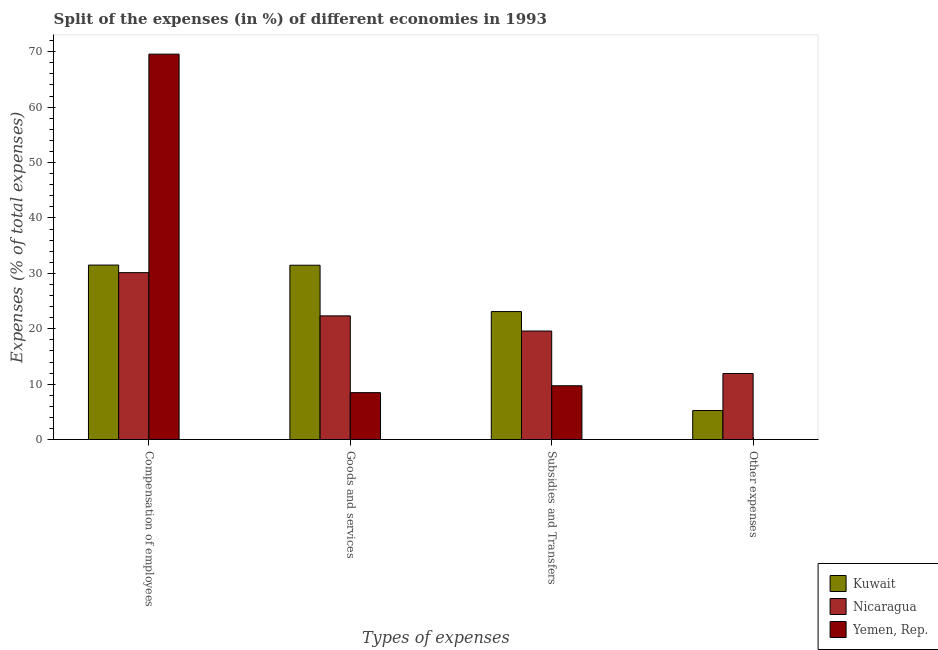How many bars are there on the 3rd tick from the right?
Provide a succinct answer. 3. What is the label of the 1st group of bars from the left?
Offer a terse response. Compensation of employees. What is the percentage of amount spent on subsidies in Kuwait?
Ensure brevity in your answer.  23.1. Across all countries, what is the maximum percentage of amount spent on other expenses?
Provide a succinct answer. 11.92. Across all countries, what is the minimum percentage of amount spent on other expenses?
Make the answer very short. 0. In which country was the percentage of amount spent on compensation of employees maximum?
Provide a succinct answer. Yemen, Rep. In which country was the percentage of amount spent on compensation of employees minimum?
Provide a succinct answer. Nicaragua. What is the total percentage of amount spent on compensation of employees in the graph?
Offer a very short reply. 131.18. What is the difference between the percentage of amount spent on other expenses in Yemen, Rep. and that in Kuwait?
Your answer should be very brief. -5.24. What is the difference between the percentage of amount spent on compensation of employees in Kuwait and the percentage of amount spent on subsidies in Yemen, Rep.?
Ensure brevity in your answer.  21.78. What is the average percentage of amount spent on other expenses per country?
Your response must be concise. 5.72. What is the difference between the percentage of amount spent on compensation of employees and percentage of amount spent on other expenses in Nicaragua?
Provide a short and direct response. 18.2. In how many countries, is the percentage of amount spent on subsidies greater than 28 %?
Your answer should be very brief. 0. What is the ratio of the percentage of amount spent on other expenses in Nicaragua to that in Kuwait?
Offer a terse response. 2.27. Is the difference between the percentage of amount spent on other expenses in Yemen, Rep. and Nicaragua greater than the difference between the percentage of amount spent on compensation of employees in Yemen, Rep. and Nicaragua?
Your answer should be compact. No. What is the difference between the highest and the second highest percentage of amount spent on goods and services?
Provide a succinct answer. 9.14. What is the difference between the highest and the lowest percentage of amount spent on goods and services?
Your answer should be very brief. 22.99. Is the sum of the percentage of amount spent on subsidies in Nicaragua and Kuwait greater than the maximum percentage of amount spent on goods and services across all countries?
Offer a very short reply. Yes. What does the 1st bar from the left in Compensation of employees represents?
Your response must be concise. Kuwait. What does the 1st bar from the right in Other expenses represents?
Offer a terse response. Yemen, Rep. How many bars are there?
Your answer should be very brief. 12. Are all the bars in the graph horizontal?
Ensure brevity in your answer.  No. How many countries are there in the graph?
Your answer should be very brief. 3. Does the graph contain grids?
Your response must be concise. No. Where does the legend appear in the graph?
Offer a very short reply. Bottom right. How many legend labels are there?
Provide a short and direct response. 3. How are the legend labels stacked?
Your answer should be compact. Vertical. What is the title of the graph?
Your answer should be compact. Split of the expenses (in %) of different economies in 1993. What is the label or title of the X-axis?
Provide a succinct answer. Types of expenses. What is the label or title of the Y-axis?
Ensure brevity in your answer.  Expenses (% of total expenses). What is the Expenses (% of total expenses) of Kuwait in Compensation of employees?
Offer a terse response. 31.5. What is the Expenses (% of total expenses) of Nicaragua in Compensation of employees?
Give a very brief answer. 30.13. What is the Expenses (% of total expenses) in Yemen, Rep. in Compensation of employees?
Give a very brief answer. 69.55. What is the Expenses (% of total expenses) of Kuwait in Goods and services?
Ensure brevity in your answer.  31.47. What is the Expenses (% of total expenses) of Nicaragua in Goods and services?
Give a very brief answer. 22.33. What is the Expenses (% of total expenses) in Yemen, Rep. in Goods and services?
Your response must be concise. 8.47. What is the Expenses (% of total expenses) of Kuwait in Subsidies and Transfers?
Offer a very short reply. 23.1. What is the Expenses (% of total expenses) of Nicaragua in Subsidies and Transfers?
Ensure brevity in your answer.  19.59. What is the Expenses (% of total expenses) in Yemen, Rep. in Subsidies and Transfers?
Your response must be concise. 9.72. What is the Expenses (% of total expenses) in Kuwait in Other expenses?
Provide a succinct answer. 5.24. What is the Expenses (% of total expenses) of Nicaragua in Other expenses?
Offer a very short reply. 11.92. What is the Expenses (% of total expenses) in Yemen, Rep. in Other expenses?
Your response must be concise. 0. Across all Types of expenses, what is the maximum Expenses (% of total expenses) of Kuwait?
Your answer should be very brief. 31.5. Across all Types of expenses, what is the maximum Expenses (% of total expenses) in Nicaragua?
Your response must be concise. 30.13. Across all Types of expenses, what is the maximum Expenses (% of total expenses) in Yemen, Rep.?
Offer a very short reply. 69.55. Across all Types of expenses, what is the minimum Expenses (% of total expenses) in Kuwait?
Provide a short and direct response. 5.24. Across all Types of expenses, what is the minimum Expenses (% of total expenses) of Nicaragua?
Give a very brief answer. 11.92. Across all Types of expenses, what is the minimum Expenses (% of total expenses) in Yemen, Rep.?
Give a very brief answer. 0. What is the total Expenses (% of total expenses) of Kuwait in the graph?
Offer a terse response. 91.31. What is the total Expenses (% of total expenses) in Nicaragua in the graph?
Keep it short and to the point. 83.97. What is the total Expenses (% of total expenses) of Yemen, Rep. in the graph?
Provide a succinct answer. 87.75. What is the difference between the Expenses (% of total expenses) in Kuwait in Compensation of employees and that in Goods and services?
Make the answer very short. 0.03. What is the difference between the Expenses (% of total expenses) of Nicaragua in Compensation of employees and that in Goods and services?
Provide a succinct answer. 7.8. What is the difference between the Expenses (% of total expenses) of Yemen, Rep. in Compensation of employees and that in Goods and services?
Keep it short and to the point. 61.08. What is the difference between the Expenses (% of total expenses) in Kuwait in Compensation of employees and that in Subsidies and Transfers?
Provide a short and direct response. 8.39. What is the difference between the Expenses (% of total expenses) in Nicaragua in Compensation of employees and that in Subsidies and Transfers?
Your response must be concise. 10.53. What is the difference between the Expenses (% of total expenses) of Yemen, Rep. in Compensation of employees and that in Subsidies and Transfers?
Provide a short and direct response. 59.84. What is the difference between the Expenses (% of total expenses) in Kuwait in Compensation of employees and that in Other expenses?
Provide a succinct answer. 26.25. What is the difference between the Expenses (% of total expenses) of Nicaragua in Compensation of employees and that in Other expenses?
Make the answer very short. 18.2. What is the difference between the Expenses (% of total expenses) of Yemen, Rep. in Compensation of employees and that in Other expenses?
Ensure brevity in your answer.  69.55. What is the difference between the Expenses (% of total expenses) in Kuwait in Goods and services and that in Subsidies and Transfers?
Your response must be concise. 8.36. What is the difference between the Expenses (% of total expenses) of Nicaragua in Goods and services and that in Subsidies and Transfers?
Your answer should be compact. 2.74. What is the difference between the Expenses (% of total expenses) in Yemen, Rep. in Goods and services and that in Subsidies and Transfers?
Keep it short and to the point. -1.24. What is the difference between the Expenses (% of total expenses) in Kuwait in Goods and services and that in Other expenses?
Keep it short and to the point. 26.22. What is the difference between the Expenses (% of total expenses) in Nicaragua in Goods and services and that in Other expenses?
Keep it short and to the point. 10.41. What is the difference between the Expenses (% of total expenses) in Yemen, Rep. in Goods and services and that in Other expenses?
Give a very brief answer. 8.47. What is the difference between the Expenses (% of total expenses) in Kuwait in Subsidies and Transfers and that in Other expenses?
Provide a short and direct response. 17.86. What is the difference between the Expenses (% of total expenses) of Nicaragua in Subsidies and Transfers and that in Other expenses?
Offer a very short reply. 7.67. What is the difference between the Expenses (% of total expenses) in Yemen, Rep. in Subsidies and Transfers and that in Other expenses?
Offer a terse response. 9.72. What is the difference between the Expenses (% of total expenses) in Kuwait in Compensation of employees and the Expenses (% of total expenses) in Nicaragua in Goods and services?
Your response must be concise. 9.17. What is the difference between the Expenses (% of total expenses) in Kuwait in Compensation of employees and the Expenses (% of total expenses) in Yemen, Rep. in Goods and services?
Keep it short and to the point. 23.02. What is the difference between the Expenses (% of total expenses) in Nicaragua in Compensation of employees and the Expenses (% of total expenses) in Yemen, Rep. in Goods and services?
Your answer should be compact. 21.65. What is the difference between the Expenses (% of total expenses) of Kuwait in Compensation of employees and the Expenses (% of total expenses) of Nicaragua in Subsidies and Transfers?
Your answer should be compact. 11.9. What is the difference between the Expenses (% of total expenses) of Kuwait in Compensation of employees and the Expenses (% of total expenses) of Yemen, Rep. in Subsidies and Transfers?
Provide a short and direct response. 21.78. What is the difference between the Expenses (% of total expenses) of Nicaragua in Compensation of employees and the Expenses (% of total expenses) of Yemen, Rep. in Subsidies and Transfers?
Ensure brevity in your answer.  20.41. What is the difference between the Expenses (% of total expenses) of Kuwait in Compensation of employees and the Expenses (% of total expenses) of Nicaragua in Other expenses?
Keep it short and to the point. 19.57. What is the difference between the Expenses (% of total expenses) in Kuwait in Compensation of employees and the Expenses (% of total expenses) in Yemen, Rep. in Other expenses?
Your answer should be compact. 31.49. What is the difference between the Expenses (% of total expenses) in Nicaragua in Compensation of employees and the Expenses (% of total expenses) in Yemen, Rep. in Other expenses?
Make the answer very short. 30.13. What is the difference between the Expenses (% of total expenses) of Kuwait in Goods and services and the Expenses (% of total expenses) of Nicaragua in Subsidies and Transfers?
Ensure brevity in your answer.  11.87. What is the difference between the Expenses (% of total expenses) of Kuwait in Goods and services and the Expenses (% of total expenses) of Yemen, Rep. in Subsidies and Transfers?
Ensure brevity in your answer.  21.75. What is the difference between the Expenses (% of total expenses) of Nicaragua in Goods and services and the Expenses (% of total expenses) of Yemen, Rep. in Subsidies and Transfers?
Your answer should be very brief. 12.61. What is the difference between the Expenses (% of total expenses) in Kuwait in Goods and services and the Expenses (% of total expenses) in Nicaragua in Other expenses?
Keep it short and to the point. 19.54. What is the difference between the Expenses (% of total expenses) in Kuwait in Goods and services and the Expenses (% of total expenses) in Yemen, Rep. in Other expenses?
Your response must be concise. 31.46. What is the difference between the Expenses (% of total expenses) of Nicaragua in Goods and services and the Expenses (% of total expenses) of Yemen, Rep. in Other expenses?
Provide a succinct answer. 22.33. What is the difference between the Expenses (% of total expenses) in Kuwait in Subsidies and Transfers and the Expenses (% of total expenses) in Nicaragua in Other expenses?
Ensure brevity in your answer.  11.18. What is the difference between the Expenses (% of total expenses) of Kuwait in Subsidies and Transfers and the Expenses (% of total expenses) of Yemen, Rep. in Other expenses?
Make the answer very short. 23.1. What is the difference between the Expenses (% of total expenses) in Nicaragua in Subsidies and Transfers and the Expenses (% of total expenses) in Yemen, Rep. in Other expenses?
Your answer should be very brief. 19.59. What is the average Expenses (% of total expenses) in Kuwait per Types of expenses?
Ensure brevity in your answer.  22.83. What is the average Expenses (% of total expenses) of Nicaragua per Types of expenses?
Your answer should be very brief. 20.99. What is the average Expenses (% of total expenses) of Yemen, Rep. per Types of expenses?
Keep it short and to the point. 21.94. What is the difference between the Expenses (% of total expenses) in Kuwait and Expenses (% of total expenses) in Nicaragua in Compensation of employees?
Your answer should be very brief. 1.37. What is the difference between the Expenses (% of total expenses) in Kuwait and Expenses (% of total expenses) in Yemen, Rep. in Compensation of employees?
Give a very brief answer. -38.06. What is the difference between the Expenses (% of total expenses) of Nicaragua and Expenses (% of total expenses) of Yemen, Rep. in Compensation of employees?
Ensure brevity in your answer.  -39.43. What is the difference between the Expenses (% of total expenses) of Kuwait and Expenses (% of total expenses) of Nicaragua in Goods and services?
Offer a very short reply. 9.14. What is the difference between the Expenses (% of total expenses) in Kuwait and Expenses (% of total expenses) in Yemen, Rep. in Goods and services?
Provide a short and direct response. 22.99. What is the difference between the Expenses (% of total expenses) in Nicaragua and Expenses (% of total expenses) in Yemen, Rep. in Goods and services?
Offer a very short reply. 13.86. What is the difference between the Expenses (% of total expenses) in Kuwait and Expenses (% of total expenses) in Nicaragua in Subsidies and Transfers?
Make the answer very short. 3.51. What is the difference between the Expenses (% of total expenses) of Kuwait and Expenses (% of total expenses) of Yemen, Rep. in Subsidies and Transfers?
Make the answer very short. 13.39. What is the difference between the Expenses (% of total expenses) of Nicaragua and Expenses (% of total expenses) of Yemen, Rep. in Subsidies and Transfers?
Your answer should be compact. 9.88. What is the difference between the Expenses (% of total expenses) in Kuwait and Expenses (% of total expenses) in Nicaragua in Other expenses?
Provide a short and direct response. -6.68. What is the difference between the Expenses (% of total expenses) of Kuwait and Expenses (% of total expenses) of Yemen, Rep. in Other expenses?
Make the answer very short. 5.24. What is the difference between the Expenses (% of total expenses) in Nicaragua and Expenses (% of total expenses) in Yemen, Rep. in Other expenses?
Keep it short and to the point. 11.92. What is the ratio of the Expenses (% of total expenses) in Nicaragua in Compensation of employees to that in Goods and services?
Your answer should be compact. 1.35. What is the ratio of the Expenses (% of total expenses) in Yemen, Rep. in Compensation of employees to that in Goods and services?
Keep it short and to the point. 8.21. What is the ratio of the Expenses (% of total expenses) in Kuwait in Compensation of employees to that in Subsidies and Transfers?
Offer a terse response. 1.36. What is the ratio of the Expenses (% of total expenses) in Nicaragua in Compensation of employees to that in Subsidies and Transfers?
Keep it short and to the point. 1.54. What is the ratio of the Expenses (% of total expenses) of Yemen, Rep. in Compensation of employees to that in Subsidies and Transfers?
Your answer should be compact. 7.16. What is the ratio of the Expenses (% of total expenses) in Kuwait in Compensation of employees to that in Other expenses?
Offer a terse response. 6.01. What is the ratio of the Expenses (% of total expenses) in Nicaragua in Compensation of employees to that in Other expenses?
Ensure brevity in your answer.  2.53. What is the ratio of the Expenses (% of total expenses) in Yemen, Rep. in Compensation of employees to that in Other expenses?
Provide a short and direct response. 4.09e+04. What is the ratio of the Expenses (% of total expenses) of Kuwait in Goods and services to that in Subsidies and Transfers?
Ensure brevity in your answer.  1.36. What is the ratio of the Expenses (% of total expenses) of Nicaragua in Goods and services to that in Subsidies and Transfers?
Your response must be concise. 1.14. What is the ratio of the Expenses (% of total expenses) of Yemen, Rep. in Goods and services to that in Subsidies and Transfers?
Your answer should be very brief. 0.87. What is the ratio of the Expenses (% of total expenses) in Nicaragua in Goods and services to that in Other expenses?
Ensure brevity in your answer.  1.87. What is the ratio of the Expenses (% of total expenses) in Yemen, Rep. in Goods and services to that in Other expenses?
Your response must be concise. 4982. What is the ratio of the Expenses (% of total expenses) of Kuwait in Subsidies and Transfers to that in Other expenses?
Your answer should be very brief. 4.41. What is the ratio of the Expenses (% of total expenses) of Nicaragua in Subsidies and Transfers to that in Other expenses?
Offer a terse response. 1.64. What is the ratio of the Expenses (% of total expenses) in Yemen, Rep. in Subsidies and Transfers to that in Other expenses?
Your answer should be compact. 5713. What is the difference between the highest and the second highest Expenses (% of total expenses) of Nicaragua?
Your answer should be very brief. 7.8. What is the difference between the highest and the second highest Expenses (% of total expenses) in Yemen, Rep.?
Ensure brevity in your answer.  59.84. What is the difference between the highest and the lowest Expenses (% of total expenses) in Kuwait?
Offer a terse response. 26.25. What is the difference between the highest and the lowest Expenses (% of total expenses) of Nicaragua?
Offer a very short reply. 18.2. What is the difference between the highest and the lowest Expenses (% of total expenses) in Yemen, Rep.?
Ensure brevity in your answer.  69.55. 